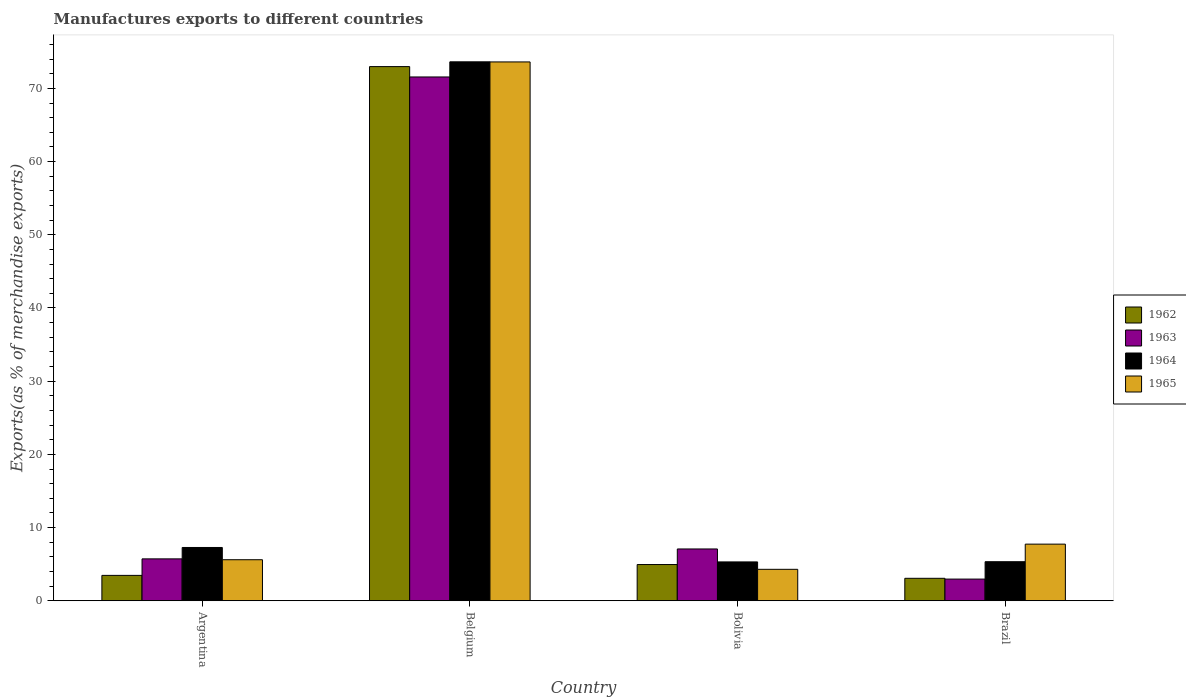How many different coloured bars are there?
Make the answer very short. 4. How many groups of bars are there?
Give a very brief answer. 4. How many bars are there on the 3rd tick from the right?
Give a very brief answer. 4. In how many cases, is the number of bars for a given country not equal to the number of legend labels?
Offer a terse response. 0. What is the percentage of exports to different countries in 1962 in Belgium?
Give a very brief answer. 72.98. Across all countries, what is the maximum percentage of exports to different countries in 1963?
Offer a terse response. 71.56. Across all countries, what is the minimum percentage of exports to different countries in 1963?
Offer a terse response. 2.96. In which country was the percentage of exports to different countries in 1965 minimum?
Make the answer very short. Bolivia. What is the total percentage of exports to different countries in 1963 in the graph?
Your answer should be compact. 87.33. What is the difference between the percentage of exports to different countries in 1962 in Bolivia and that in Brazil?
Ensure brevity in your answer.  1.88. What is the difference between the percentage of exports to different countries in 1963 in Belgium and the percentage of exports to different countries in 1962 in Argentina?
Offer a very short reply. 68.1. What is the average percentage of exports to different countries in 1963 per country?
Ensure brevity in your answer.  21.83. What is the difference between the percentage of exports to different countries of/in 1965 and percentage of exports to different countries of/in 1963 in Argentina?
Give a very brief answer. -0.12. What is the ratio of the percentage of exports to different countries in 1963 in Bolivia to that in Brazil?
Provide a succinct answer. 2.39. Is the percentage of exports to different countries in 1963 in Argentina less than that in Bolivia?
Your response must be concise. Yes. What is the difference between the highest and the second highest percentage of exports to different countries in 1962?
Provide a succinct answer. 69.51. What is the difference between the highest and the lowest percentage of exports to different countries in 1963?
Offer a terse response. 68.6. Is the sum of the percentage of exports to different countries in 1963 in Bolivia and Brazil greater than the maximum percentage of exports to different countries in 1965 across all countries?
Your answer should be compact. No. Is it the case that in every country, the sum of the percentage of exports to different countries in 1965 and percentage of exports to different countries in 1962 is greater than the sum of percentage of exports to different countries in 1964 and percentage of exports to different countries in 1963?
Make the answer very short. No. What does the 4th bar from the left in Bolivia represents?
Your answer should be compact. 1965. Is it the case that in every country, the sum of the percentage of exports to different countries in 1964 and percentage of exports to different countries in 1962 is greater than the percentage of exports to different countries in 1965?
Your response must be concise. Yes. How many bars are there?
Provide a succinct answer. 16. How many countries are there in the graph?
Your answer should be compact. 4. Does the graph contain any zero values?
Offer a very short reply. No. Does the graph contain grids?
Give a very brief answer. No. How are the legend labels stacked?
Give a very brief answer. Vertical. What is the title of the graph?
Provide a succinct answer. Manufactures exports to different countries. What is the label or title of the X-axis?
Your answer should be very brief. Country. What is the label or title of the Y-axis?
Offer a very short reply. Exports(as % of merchandise exports). What is the Exports(as % of merchandise exports) of 1962 in Argentina?
Make the answer very short. 3.47. What is the Exports(as % of merchandise exports) in 1963 in Argentina?
Offer a very short reply. 5.73. What is the Exports(as % of merchandise exports) in 1964 in Argentina?
Your answer should be compact. 7.28. What is the Exports(as % of merchandise exports) of 1965 in Argentina?
Keep it short and to the point. 5.61. What is the Exports(as % of merchandise exports) in 1962 in Belgium?
Ensure brevity in your answer.  72.98. What is the Exports(as % of merchandise exports) in 1963 in Belgium?
Provide a succinct answer. 71.56. What is the Exports(as % of merchandise exports) of 1964 in Belgium?
Keep it short and to the point. 73.63. What is the Exports(as % of merchandise exports) of 1965 in Belgium?
Offer a very short reply. 73.62. What is the Exports(as % of merchandise exports) in 1962 in Bolivia?
Give a very brief answer. 4.95. What is the Exports(as % of merchandise exports) of 1963 in Bolivia?
Make the answer very short. 7.08. What is the Exports(as % of merchandise exports) of 1964 in Bolivia?
Provide a succinct answer. 5.31. What is the Exports(as % of merchandise exports) of 1965 in Bolivia?
Provide a succinct answer. 4.3. What is the Exports(as % of merchandise exports) of 1962 in Brazil?
Make the answer very short. 3.07. What is the Exports(as % of merchandise exports) of 1963 in Brazil?
Provide a short and direct response. 2.96. What is the Exports(as % of merchandise exports) in 1964 in Brazil?
Your answer should be compact. 5.34. What is the Exports(as % of merchandise exports) of 1965 in Brazil?
Provide a short and direct response. 7.74. Across all countries, what is the maximum Exports(as % of merchandise exports) in 1962?
Ensure brevity in your answer.  72.98. Across all countries, what is the maximum Exports(as % of merchandise exports) of 1963?
Your answer should be very brief. 71.56. Across all countries, what is the maximum Exports(as % of merchandise exports) in 1964?
Give a very brief answer. 73.63. Across all countries, what is the maximum Exports(as % of merchandise exports) of 1965?
Keep it short and to the point. 73.62. Across all countries, what is the minimum Exports(as % of merchandise exports) in 1962?
Your response must be concise. 3.07. Across all countries, what is the minimum Exports(as % of merchandise exports) in 1963?
Offer a very short reply. 2.96. Across all countries, what is the minimum Exports(as % of merchandise exports) of 1964?
Provide a succinct answer. 5.31. Across all countries, what is the minimum Exports(as % of merchandise exports) of 1965?
Your answer should be very brief. 4.3. What is the total Exports(as % of merchandise exports) of 1962 in the graph?
Make the answer very short. 84.47. What is the total Exports(as % of merchandise exports) in 1963 in the graph?
Your response must be concise. 87.33. What is the total Exports(as % of merchandise exports) in 1964 in the graph?
Keep it short and to the point. 91.56. What is the total Exports(as % of merchandise exports) of 1965 in the graph?
Your answer should be compact. 91.26. What is the difference between the Exports(as % of merchandise exports) in 1962 in Argentina and that in Belgium?
Offer a terse response. -69.51. What is the difference between the Exports(as % of merchandise exports) of 1963 in Argentina and that in Belgium?
Give a very brief answer. -65.84. What is the difference between the Exports(as % of merchandise exports) in 1964 in Argentina and that in Belgium?
Ensure brevity in your answer.  -66.35. What is the difference between the Exports(as % of merchandise exports) of 1965 in Argentina and that in Belgium?
Offer a very short reply. -68.01. What is the difference between the Exports(as % of merchandise exports) of 1962 in Argentina and that in Bolivia?
Make the answer very short. -1.48. What is the difference between the Exports(as % of merchandise exports) in 1963 in Argentina and that in Bolivia?
Offer a terse response. -1.35. What is the difference between the Exports(as % of merchandise exports) in 1964 in Argentina and that in Bolivia?
Provide a short and direct response. 1.97. What is the difference between the Exports(as % of merchandise exports) in 1965 in Argentina and that in Bolivia?
Ensure brevity in your answer.  1.31. What is the difference between the Exports(as % of merchandise exports) of 1962 in Argentina and that in Brazil?
Your answer should be compact. 0.4. What is the difference between the Exports(as % of merchandise exports) of 1963 in Argentina and that in Brazil?
Your answer should be very brief. 2.76. What is the difference between the Exports(as % of merchandise exports) of 1964 in Argentina and that in Brazil?
Give a very brief answer. 1.95. What is the difference between the Exports(as % of merchandise exports) of 1965 in Argentina and that in Brazil?
Offer a very short reply. -2.13. What is the difference between the Exports(as % of merchandise exports) of 1962 in Belgium and that in Bolivia?
Offer a terse response. 68.03. What is the difference between the Exports(as % of merchandise exports) of 1963 in Belgium and that in Bolivia?
Offer a terse response. 64.48. What is the difference between the Exports(as % of merchandise exports) in 1964 in Belgium and that in Bolivia?
Give a very brief answer. 68.32. What is the difference between the Exports(as % of merchandise exports) in 1965 in Belgium and that in Bolivia?
Offer a terse response. 69.32. What is the difference between the Exports(as % of merchandise exports) in 1962 in Belgium and that in Brazil?
Your response must be concise. 69.91. What is the difference between the Exports(as % of merchandise exports) in 1963 in Belgium and that in Brazil?
Provide a short and direct response. 68.6. What is the difference between the Exports(as % of merchandise exports) in 1964 in Belgium and that in Brazil?
Your answer should be compact. 68.3. What is the difference between the Exports(as % of merchandise exports) of 1965 in Belgium and that in Brazil?
Provide a short and direct response. 65.88. What is the difference between the Exports(as % of merchandise exports) of 1962 in Bolivia and that in Brazil?
Offer a very short reply. 1.88. What is the difference between the Exports(as % of merchandise exports) of 1963 in Bolivia and that in Brazil?
Ensure brevity in your answer.  4.12. What is the difference between the Exports(as % of merchandise exports) of 1964 in Bolivia and that in Brazil?
Offer a very short reply. -0.03. What is the difference between the Exports(as % of merchandise exports) of 1965 in Bolivia and that in Brazil?
Keep it short and to the point. -3.44. What is the difference between the Exports(as % of merchandise exports) of 1962 in Argentina and the Exports(as % of merchandise exports) of 1963 in Belgium?
Offer a terse response. -68.1. What is the difference between the Exports(as % of merchandise exports) in 1962 in Argentina and the Exports(as % of merchandise exports) in 1964 in Belgium?
Offer a very short reply. -70.16. What is the difference between the Exports(as % of merchandise exports) in 1962 in Argentina and the Exports(as % of merchandise exports) in 1965 in Belgium?
Offer a terse response. -70.15. What is the difference between the Exports(as % of merchandise exports) in 1963 in Argentina and the Exports(as % of merchandise exports) in 1964 in Belgium?
Your response must be concise. -67.91. What is the difference between the Exports(as % of merchandise exports) of 1963 in Argentina and the Exports(as % of merchandise exports) of 1965 in Belgium?
Offer a very short reply. -67.89. What is the difference between the Exports(as % of merchandise exports) of 1964 in Argentina and the Exports(as % of merchandise exports) of 1965 in Belgium?
Your response must be concise. -66.33. What is the difference between the Exports(as % of merchandise exports) in 1962 in Argentina and the Exports(as % of merchandise exports) in 1963 in Bolivia?
Your answer should be compact. -3.61. What is the difference between the Exports(as % of merchandise exports) in 1962 in Argentina and the Exports(as % of merchandise exports) in 1964 in Bolivia?
Give a very brief answer. -1.84. What is the difference between the Exports(as % of merchandise exports) in 1962 in Argentina and the Exports(as % of merchandise exports) in 1965 in Bolivia?
Your answer should be compact. -0.83. What is the difference between the Exports(as % of merchandise exports) of 1963 in Argentina and the Exports(as % of merchandise exports) of 1964 in Bolivia?
Provide a short and direct response. 0.42. What is the difference between the Exports(as % of merchandise exports) in 1963 in Argentina and the Exports(as % of merchandise exports) in 1965 in Bolivia?
Provide a short and direct response. 1.43. What is the difference between the Exports(as % of merchandise exports) of 1964 in Argentina and the Exports(as % of merchandise exports) of 1965 in Bolivia?
Provide a short and direct response. 2.98. What is the difference between the Exports(as % of merchandise exports) of 1962 in Argentina and the Exports(as % of merchandise exports) of 1963 in Brazil?
Give a very brief answer. 0.51. What is the difference between the Exports(as % of merchandise exports) of 1962 in Argentina and the Exports(as % of merchandise exports) of 1964 in Brazil?
Make the answer very short. -1.87. What is the difference between the Exports(as % of merchandise exports) in 1962 in Argentina and the Exports(as % of merchandise exports) in 1965 in Brazil?
Make the answer very short. -4.27. What is the difference between the Exports(as % of merchandise exports) of 1963 in Argentina and the Exports(as % of merchandise exports) of 1964 in Brazil?
Make the answer very short. 0.39. What is the difference between the Exports(as % of merchandise exports) of 1963 in Argentina and the Exports(as % of merchandise exports) of 1965 in Brazil?
Offer a very short reply. -2.01. What is the difference between the Exports(as % of merchandise exports) of 1964 in Argentina and the Exports(as % of merchandise exports) of 1965 in Brazil?
Keep it short and to the point. -0.46. What is the difference between the Exports(as % of merchandise exports) of 1962 in Belgium and the Exports(as % of merchandise exports) of 1963 in Bolivia?
Provide a succinct answer. 65.9. What is the difference between the Exports(as % of merchandise exports) in 1962 in Belgium and the Exports(as % of merchandise exports) in 1964 in Bolivia?
Offer a very short reply. 67.67. What is the difference between the Exports(as % of merchandise exports) in 1962 in Belgium and the Exports(as % of merchandise exports) in 1965 in Bolivia?
Your answer should be compact. 68.68. What is the difference between the Exports(as % of merchandise exports) of 1963 in Belgium and the Exports(as % of merchandise exports) of 1964 in Bolivia?
Keep it short and to the point. 66.25. What is the difference between the Exports(as % of merchandise exports) of 1963 in Belgium and the Exports(as % of merchandise exports) of 1965 in Bolivia?
Ensure brevity in your answer.  67.27. What is the difference between the Exports(as % of merchandise exports) in 1964 in Belgium and the Exports(as % of merchandise exports) in 1965 in Bolivia?
Make the answer very short. 69.34. What is the difference between the Exports(as % of merchandise exports) in 1962 in Belgium and the Exports(as % of merchandise exports) in 1963 in Brazil?
Provide a short and direct response. 70.02. What is the difference between the Exports(as % of merchandise exports) of 1962 in Belgium and the Exports(as % of merchandise exports) of 1964 in Brazil?
Offer a terse response. 67.64. What is the difference between the Exports(as % of merchandise exports) in 1962 in Belgium and the Exports(as % of merchandise exports) in 1965 in Brazil?
Make the answer very short. 65.24. What is the difference between the Exports(as % of merchandise exports) of 1963 in Belgium and the Exports(as % of merchandise exports) of 1964 in Brazil?
Your response must be concise. 66.23. What is the difference between the Exports(as % of merchandise exports) in 1963 in Belgium and the Exports(as % of merchandise exports) in 1965 in Brazil?
Offer a very short reply. 63.82. What is the difference between the Exports(as % of merchandise exports) in 1964 in Belgium and the Exports(as % of merchandise exports) in 1965 in Brazil?
Provide a succinct answer. 65.89. What is the difference between the Exports(as % of merchandise exports) in 1962 in Bolivia and the Exports(as % of merchandise exports) in 1963 in Brazil?
Your answer should be very brief. 1.99. What is the difference between the Exports(as % of merchandise exports) in 1962 in Bolivia and the Exports(as % of merchandise exports) in 1964 in Brazil?
Your response must be concise. -0.39. What is the difference between the Exports(as % of merchandise exports) in 1962 in Bolivia and the Exports(as % of merchandise exports) in 1965 in Brazil?
Keep it short and to the point. -2.79. What is the difference between the Exports(as % of merchandise exports) of 1963 in Bolivia and the Exports(as % of merchandise exports) of 1964 in Brazil?
Offer a very short reply. 1.74. What is the difference between the Exports(as % of merchandise exports) in 1963 in Bolivia and the Exports(as % of merchandise exports) in 1965 in Brazil?
Make the answer very short. -0.66. What is the difference between the Exports(as % of merchandise exports) in 1964 in Bolivia and the Exports(as % of merchandise exports) in 1965 in Brazil?
Offer a very short reply. -2.43. What is the average Exports(as % of merchandise exports) of 1962 per country?
Make the answer very short. 21.12. What is the average Exports(as % of merchandise exports) of 1963 per country?
Your answer should be compact. 21.83. What is the average Exports(as % of merchandise exports) in 1964 per country?
Your answer should be very brief. 22.89. What is the average Exports(as % of merchandise exports) in 1965 per country?
Offer a very short reply. 22.82. What is the difference between the Exports(as % of merchandise exports) of 1962 and Exports(as % of merchandise exports) of 1963 in Argentina?
Provide a succinct answer. -2.26. What is the difference between the Exports(as % of merchandise exports) of 1962 and Exports(as % of merchandise exports) of 1964 in Argentina?
Ensure brevity in your answer.  -3.81. What is the difference between the Exports(as % of merchandise exports) of 1962 and Exports(as % of merchandise exports) of 1965 in Argentina?
Provide a short and direct response. -2.14. What is the difference between the Exports(as % of merchandise exports) of 1963 and Exports(as % of merchandise exports) of 1964 in Argentina?
Your answer should be compact. -1.56. What is the difference between the Exports(as % of merchandise exports) of 1963 and Exports(as % of merchandise exports) of 1965 in Argentina?
Provide a short and direct response. 0.12. What is the difference between the Exports(as % of merchandise exports) of 1964 and Exports(as % of merchandise exports) of 1965 in Argentina?
Ensure brevity in your answer.  1.67. What is the difference between the Exports(as % of merchandise exports) in 1962 and Exports(as % of merchandise exports) in 1963 in Belgium?
Your answer should be compact. 1.42. What is the difference between the Exports(as % of merchandise exports) in 1962 and Exports(as % of merchandise exports) in 1964 in Belgium?
Offer a terse response. -0.65. What is the difference between the Exports(as % of merchandise exports) of 1962 and Exports(as % of merchandise exports) of 1965 in Belgium?
Your answer should be compact. -0.64. What is the difference between the Exports(as % of merchandise exports) in 1963 and Exports(as % of merchandise exports) in 1964 in Belgium?
Ensure brevity in your answer.  -2.07. What is the difference between the Exports(as % of merchandise exports) of 1963 and Exports(as % of merchandise exports) of 1965 in Belgium?
Provide a succinct answer. -2.05. What is the difference between the Exports(as % of merchandise exports) in 1964 and Exports(as % of merchandise exports) in 1965 in Belgium?
Your answer should be compact. 0.02. What is the difference between the Exports(as % of merchandise exports) in 1962 and Exports(as % of merchandise exports) in 1963 in Bolivia?
Offer a very short reply. -2.13. What is the difference between the Exports(as % of merchandise exports) of 1962 and Exports(as % of merchandise exports) of 1964 in Bolivia?
Ensure brevity in your answer.  -0.36. What is the difference between the Exports(as % of merchandise exports) in 1962 and Exports(as % of merchandise exports) in 1965 in Bolivia?
Your answer should be compact. 0.65. What is the difference between the Exports(as % of merchandise exports) of 1963 and Exports(as % of merchandise exports) of 1964 in Bolivia?
Make the answer very short. 1.77. What is the difference between the Exports(as % of merchandise exports) of 1963 and Exports(as % of merchandise exports) of 1965 in Bolivia?
Your response must be concise. 2.78. What is the difference between the Exports(as % of merchandise exports) of 1964 and Exports(as % of merchandise exports) of 1965 in Bolivia?
Provide a succinct answer. 1.01. What is the difference between the Exports(as % of merchandise exports) of 1962 and Exports(as % of merchandise exports) of 1963 in Brazil?
Your response must be concise. 0.11. What is the difference between the Exports(as % of merchandise exports) of 1962 and Exports(as % of merchandise exports) of 1964 in Brazil?
Keep it short and to the point. -2.27. What is the difference between the Exports(as % of merchandise exports) in 1962 and Exports(as % of merchandise exports) in 1965 in Brazil?
Provide a succinct answer. -4.67. What is the difference between the Exports(as % of merchandise exports) of 1963 and Exports(as % of merchandise exports) of 1964 in Brazil?
Your response must be concise. -2.37. What is the difference between the Exports(as % of merchandise exports) in 1963 and Exports(as % of merchandise exports) in 1965 in Brazil?
Your response must be concise. -4.78. What is the difference between the Exports(as % of merchandise exports) in 1964 and Exports(as % of merchandise exports) in 1965 in Brazil?
Ensure brevity in your answer.  -2.4. What is the ratio of the Exports(as % of merchandise exports) of 1962 in Argentina to that in Belgium?
Provide a short and direct response. 0.05. What is the ratio of the Exports(as % of merchandise exports) of 1963 in Argentina to that in Belgium?
Give a very brief answer. 0.08. What is the ratio of the Exports(as % of merchandise exports) in 1964 in Argentina to that in Belgium?
Keep it short and to the point. 0.1. What is the ratio of the Exports(as % of merchandise exports) of 1965 in Argentina to that in Belgium?
Offer a terse response. 0.08. What is the ratio of the Exports(as % of merchandise exports) in 1962 in Argentina to that in Bolivia?
Give a very brief answer. 0.7. What is the ratio of the Exports(as % of merchandise exports) of 1963 in Argentina to that in Bolivia?
Provide a succinct answer. 0.81. What is the ratio of the Exports(as % of merchandise exports) of 1964 in Argentina to that in Bolivia?
Offer a terse response. 1.37. What is the ratio of the Exports(as % of merchandise exports) in 1965 in Argentina to that in Bolivia?
Offer a very short reply. 1.31. What is the ratio of the Exports(as % of merchandise exports) of 1962 in Argentina to that in Brazil?
Offer a terse response. 1.13. What is the ratio of the Exports(as % of merchandise exports) of 1963 in Argentina to that in Brazil?
Ensure brevity in your answer.  1.93. What is the ratio of the Exports(as % of merchandise exports) of 1964 in Argentina to that in Brazil?
Provide a short and direct response. 1.36. What is the ratio of the Exports(as % of merchandise exports) of 1965 in Argentina to that in Brazil?
Your answer should be very brief. 0.72. What is the ratio of the Exports(as % of merchandise exports) in 1962 in Belgium to that in Bolivia?
Offer a terse response. 14.74. What is the ratio of the Exports(as % of merchandise exports) in 1963 in Belgium to that in Bolivia?
Provide a succinct answer. 10.11. What is the ratio of the Exports(as % of merchandise exports) of 1964 in Belgium to that in Bolivia?
Provide a short and direct response. 13.87. What is the ratio of the Exports(as % of merchandise exports) in 1965 in Belgium to that in Bolivia?
Offer a very short reply. 17.13. What is the ratio of the Exports(as % of merchandise exports) of 1962 in Belgium to that in Brazil?
Provide a short and direct response. 23.77. What is the ratio of the Exports(as % of merchandise exports) of 1963 in Belgium to that in Brazil?
Your answer should be compact. 24.16. What is the ratio of the Exports(as % of merchandise exports) in 1964 in Belgium to that in Brazil?
Make the answer very short. 13.8. What is the ratio of the Exports(as % of merchandise exports) in 1965 in Belgium to that in Brazil?
Ensure brevity in your answer.  9.51. What is the ratio of the Exports(as % of merchandise exports) of 1962 in Bolivia to that in Brazil?
Provide a succinct answer. 1.61. What is the ratio of the Exports(as % of merchandise exports) of 1963 in Bolivia to that in Brazil?
Your response must be concise. 2.39. What is the ratio of the Exports(as % of merchandise exports) of 1965 in Bolivia to that in Brazil?
Give a very brief answer. 0.56. What is the difference between the highest and the second highest Exports(as % of merchandise exports) of 1962?
Make the answer very short. 68.03. What is the difference between the highest and the second highest Exports(as % of merchandise exports) in 1963?
Ensure brevity in your answer.  64.48. What is the difference between the highest and the second highest Exports(as % of merchandise exports) of 1964?
Provide a short and direct response. 66.35. What is the difference between the highest and the second highest Exports(as % of merchandise exports) in 1965?
Provide a short and direct response. 65.88. What is the difference between the highest and the lowest Exports(as % of merchandise exports) in 1962?
Your answer should be very brief. 69.91. What is the difference between the highest and the lowest Exports(as % of merchandise exports) in 1963?
Make the answer very short. 68.6. What is the difference between the highest and the lowest Exports(as % of merchandise exports) of 1964?
Provide a succinct answer. 68.32. What is the difference between the highest and the lowest Exports(as % of merchandise exports) of 1965?
Make the answer very short. 69.32. 